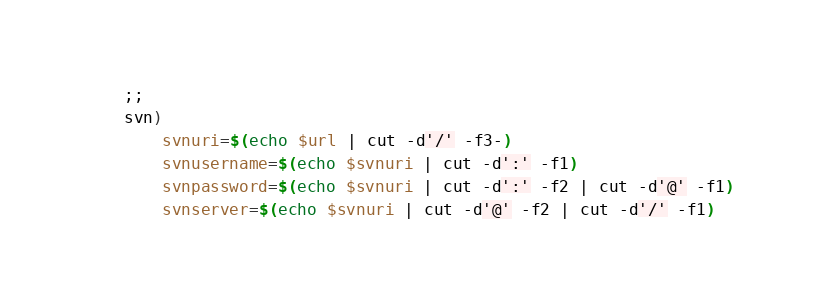Convert code to text. <code><loc_0><loc_0><loc_500><loc_500><_Bash_>    ;;
    svn)
        svnuri=$(echo $url | cut -d'/' -f3-)
        svnusername=$(echo $svnuri | cut -d':' -f1)
        svnpassword=$(echo $svnuri | cut -d':' -f2 | cut -d'@' -f1)
        svnserver=$(echo $svnuri | cut -d'@' -f2 | cut -d'/' -f1)</code> 